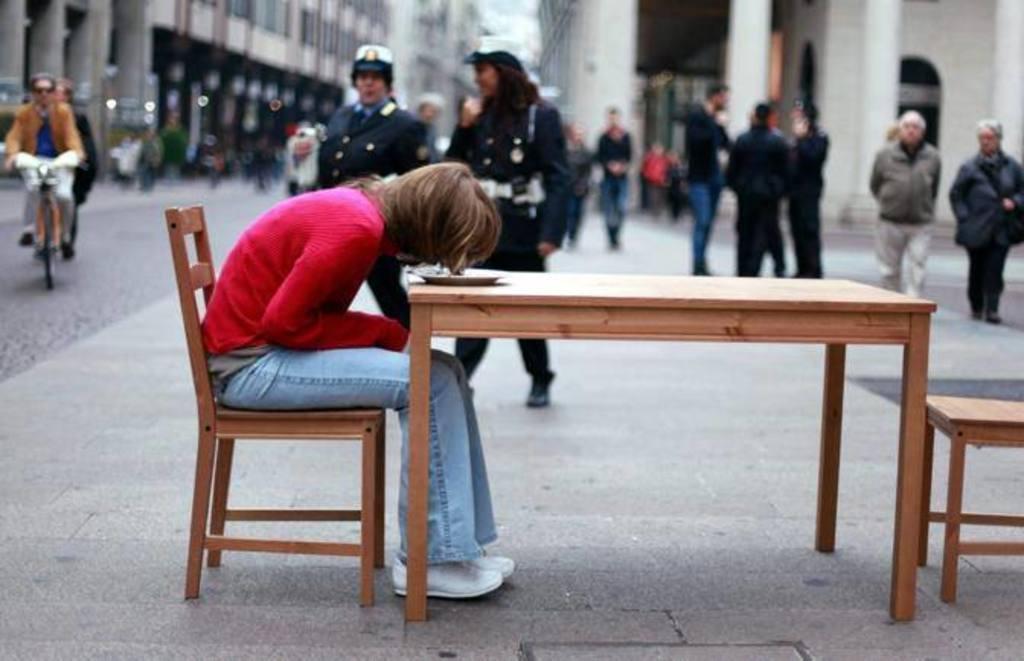Describe this image in one or two sentences. There is a group of a people. In the center we have a woman. She is sitting on a chair. There is a table. There is a plate on a table. We can see in the background there is a buildings,pillars and road. 